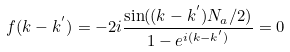<formula> <loc_0><loc_0><loc_500><loc_500>f ( k - k ^ { ^ { \prime } } ) = - 2 i \frac { \sin ( ( k - k ^ { ^ { \prime } } ) N _ { a } / 2 ) } { 1 - e ^ { i ( k - k ^ { ^ { \prime } } ) } } = 0</formula> 